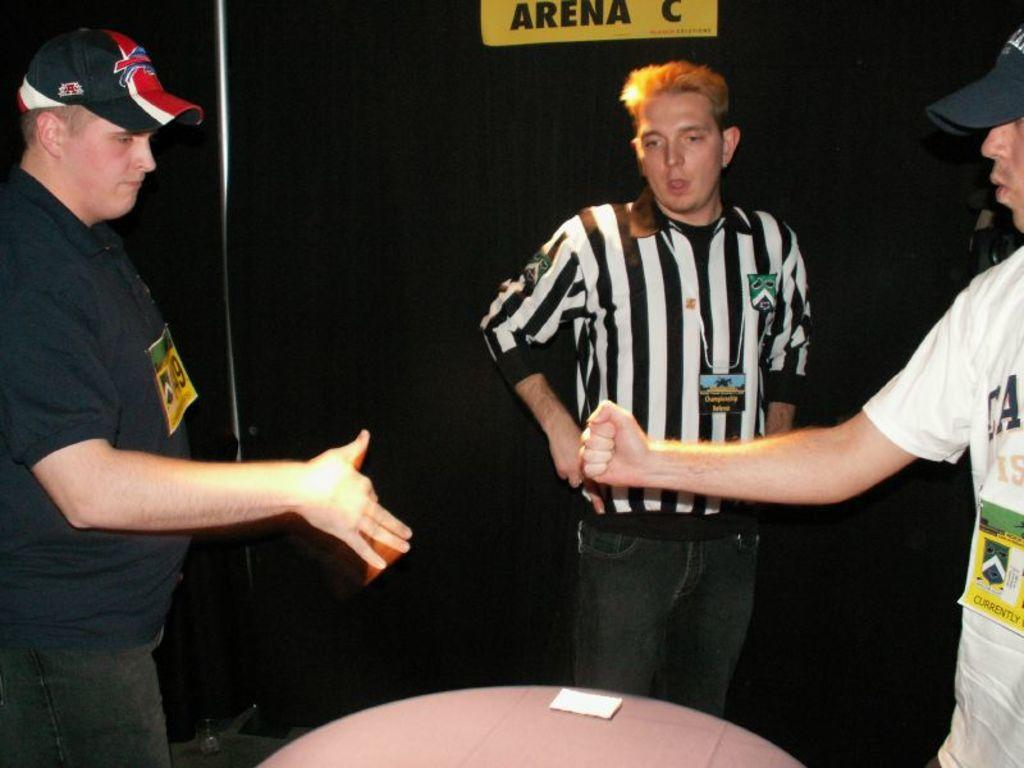<image>
Provide a brief description of the given image. Referee standing under a yellow sign that says Arena C. 